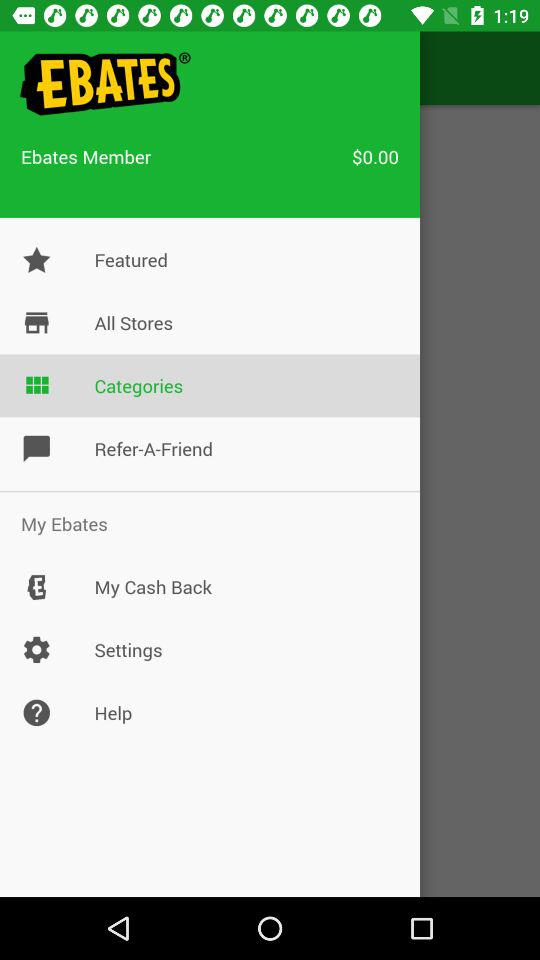How much cash is there in my "Ebates" account? There is no cash in the account. 